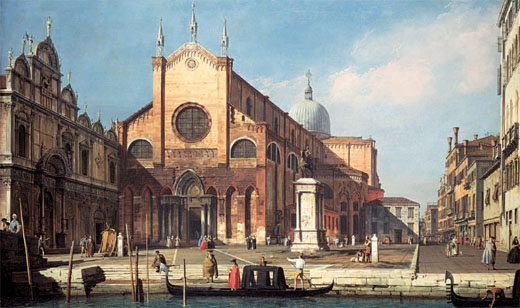Describe a day in the life of a merchant in this Venetian cityscape. A day in the life of a merchant in this Venetian cityscape is bustling with activity and trade. As dawn breaks, the merchant prepares his wares – meticulously arranging spices, silks, and other goods brought from far-off lands. His kiosk, set up in the lively square before the church, quickly draws locals and travelers. Throughout the day, he's engaged in vibrant exchanges, haggling prices, and enticing customers with stories of his goods’ origins. By noon, the merchant partakes in a hearty meal, perhaps sharing bread and cheese with fellow traders. As evening falls, he tallies his earnings, reflects on the day’s successes, and packs up, ready to repeat the cycle tomorrow. This life, intertwined with the ebb and flow of Venice's vigorous market culture, defines the rhythm of his existence. 